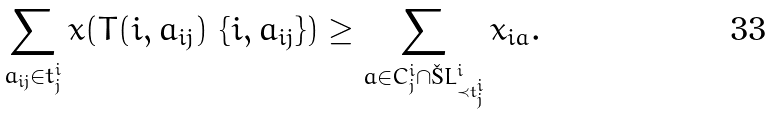Convert formula to latex. <formula><loc_0><loc_0><loc_500><loc_500>\sum _ { a _ { i j } \in t ^ { i } _ { j } } x ( T ( i , a _ { i j } ) \ \{ i , a _ { i j } \} ) \geq \sum _ { a \in C ^ { i } _ { j } \cap \L L ^ { i } _ { \prec t ^ { i } _ { j } } } x _ { i a } .</formula> 